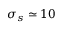Convert formula to latex. <formula><loc_0><loc_0><loc_500><loc_500>\sigma _ { s } \simeq 1 0</formula> 